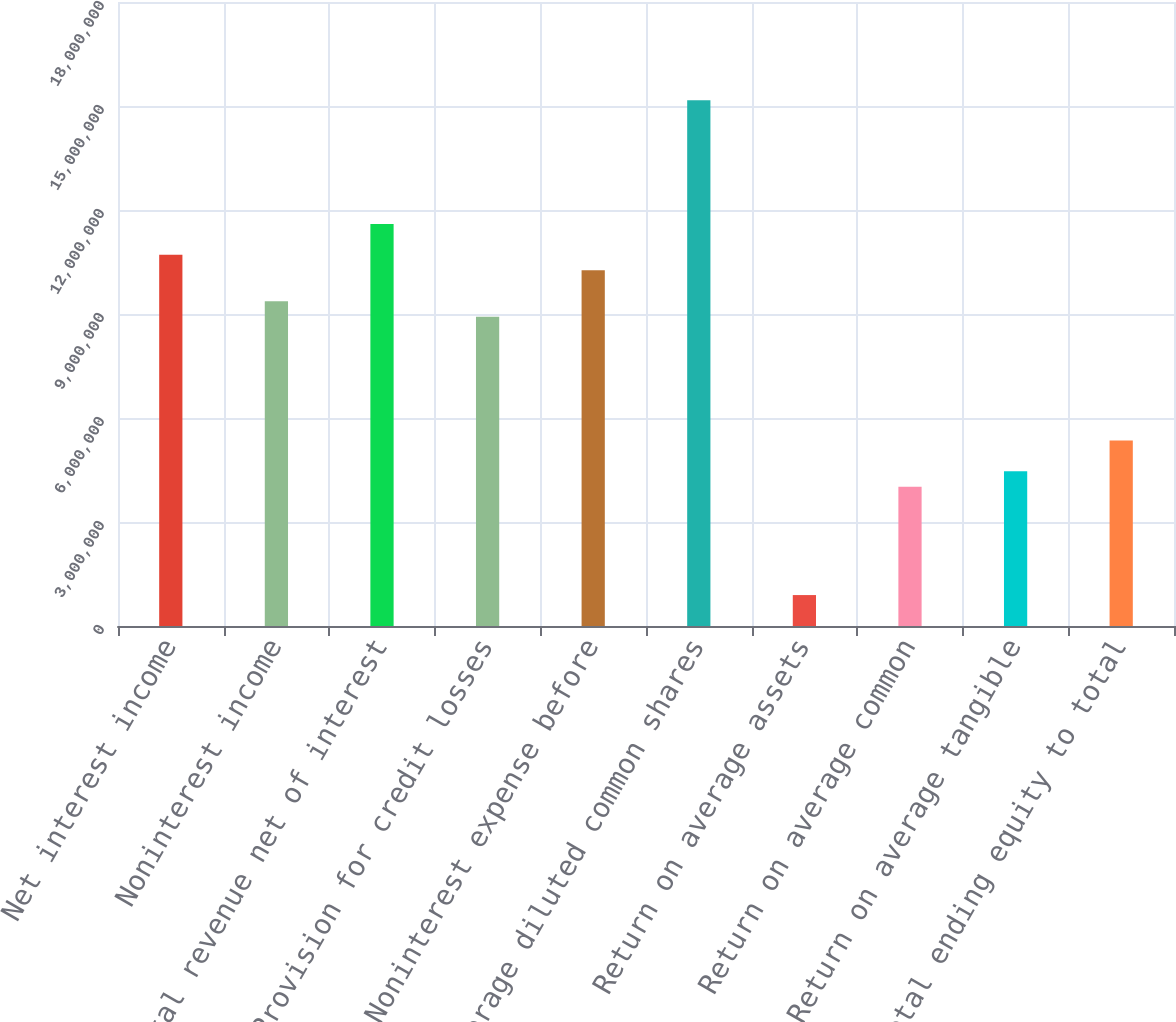Convert chart to OTSL. <chart><loc_0><loc_0><loc_500><loc_500><bar_chart><fcel>Net interest income<fcel>Noninterest income<fcel>Total revenue net of interest<fcel>Provision for credit losses<fcel>Noninterest expense before<fcel>Average diluted common shares<fcel>Return on average assets<fcel>Return on average common<fcel>Return on average tangible<fcel>Total ending equity to total<nl><fcel>1.07069e+07<fcel>9.36852e+06<fcel>1.15991e+07<fcel>8.9224e+06<fcel>1.02608e+07<fcel>1.51681e+07<fcel>892240<fcel>4.01508e+06<fcel>4.4612e+06<fcel>5.35344e+06<nl></chart> 